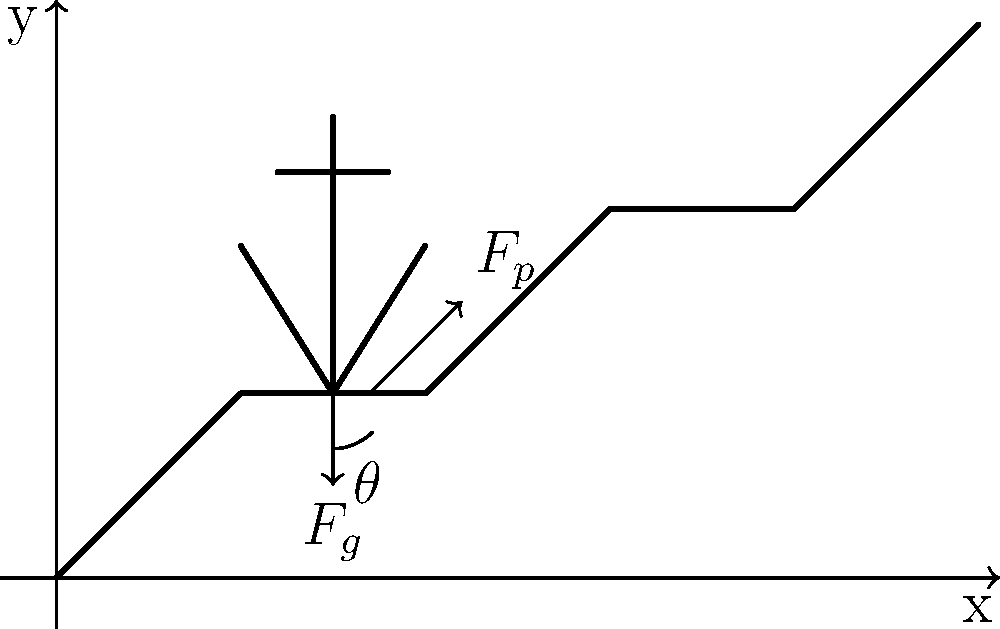As you ascend the stairs to enter the embassy building in your formal attire, consider the biomechanics of walking up stairs. If the angle between the horizontal plane and the line connecting two consecutive step edges is $\theta = 30^\circ$, what is the ratio of the propulsive force ($F_p$) to the gravitational force ($F_g$) required to maintain a constant velocity up the stairs, assuming no friction? To solve this problem, we need to follow these steps:

1. Identify the forces acting on the body:
   - Gravitational force ($F_g$) acting downward
   - Propulsive force ($F_p$) acting parallel to the staircase

2. Resolve the forces into components parallel to the stairs:
   - $F_g$ parallel component: $F_g \sin \theta$
   - $F_p$ is already parallel to the stairs

3. For constant velocity motion, the forces must be in equilibrium:
   $F_p = F_g \sin \theta$

4. Express the ratio of $F_p$ to $F_g$:
   $\frac{F_p}{F_g} = \sin \theta$

5. Calculate the ratio using the given angle:
   $\frac{F_p}{F_g} = \sin 30^\circ = \frac{1}{2}$

Therefore, the ratio of the propulsive force to the gravitational force required to maintain a constant velocity up the stairs is $1:2$ or $0.5$.
Answer: $0.5$ or $\frac{1}{2}$ 